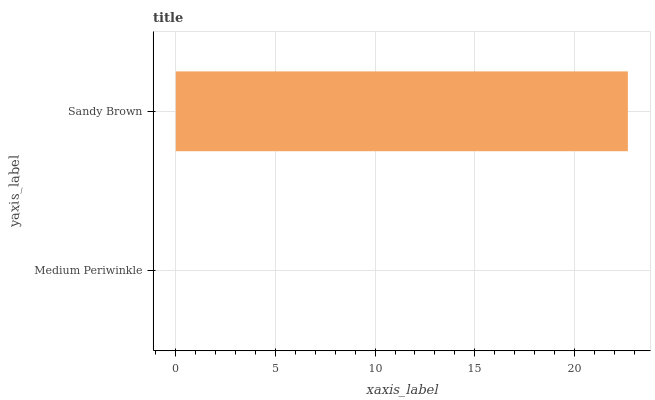Is Medium Periwinkle the minimum?
Answer yes or no. Yes. Is Sandy Brown the maximum?
Answer yes or no. Yes. Is Sandy Brown the minimum?
Answer yes or no. No. Is Sandy Brown greater than Medium Periwinkle?
Answer yes or no. Yes. Is Medium Periwinkle less than Sandy Brown?
Answer yes or no. Yes. Is Medium Periwinkle greater than Sandy Brown?
Answer yes or no. No. Is Sandy Brown less than Medium Periwinkle?
Answer yes or no. No. Is Sandy Brown the high median?
Answer yes or no. Yes. Is Medium Periwinkle the low median?
Answer yes or no. Yes. Is Medium Periwinkle the high median?
Answer yes or no. No. Is Sandy Brown the low median?
Answer yes or no. No. 